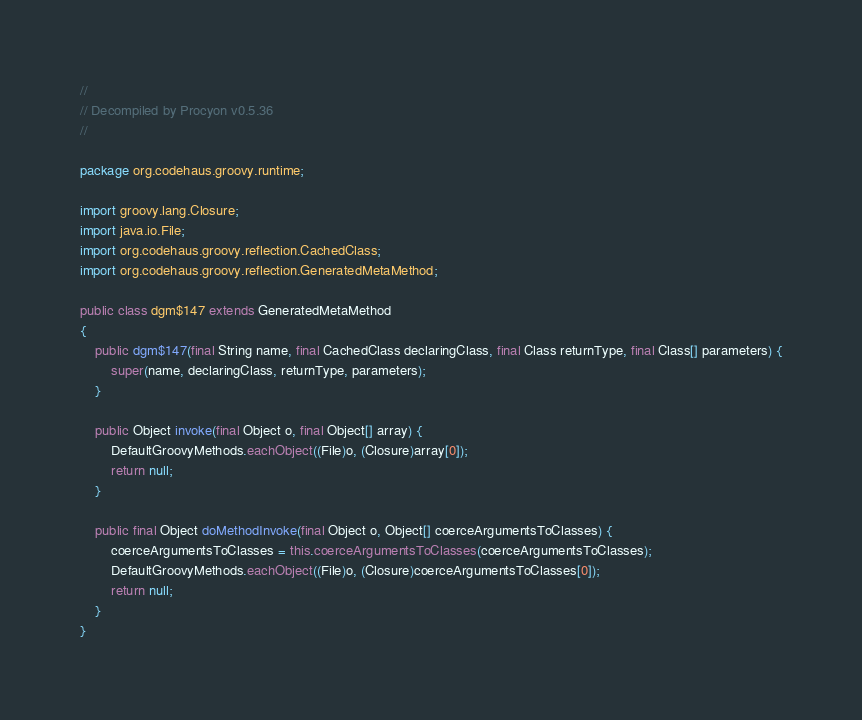<code> <loc_0><loc_0><loc_500><loc_500><_Java_>// 
// Decompiled by Procyon v0.5.36
// 

package org.codehaus.groovy.runtime;

import groovy.lang.Closure;
import java.io.File;
import org.codehaus.groovy.reflection.CachedClass;
import org.codehaus.groovy.reflection.GeneratedMetaMethod;

public class dgm$147 extends GeneratedMetaMethod
{
    public dgm$147(final String name, final CachedClass declaringClass, final Class returnType, final Class[] parameters) {
        super(name, declaringClass, returnType, parameters);
    }
    
    public Object invoke(final Object o, final Object[] array) {
        DefaultGroovyMethods.eachObject((File)o, (Closure)array[0]);
        return null;
    }
    
    public final Object doMethodInvoke(final Object o, Object[] coerceArgumentsToClasses) {
        coerceArgumentsToClasses = this.coerceArgumentsToClasses(coerceArgumentsToClasses);
        DefaultGroovyMethods.eachObject((File)o, (Closure)coerceArgumentsToClasses[0]);
        return null;
    }
}
</code> 